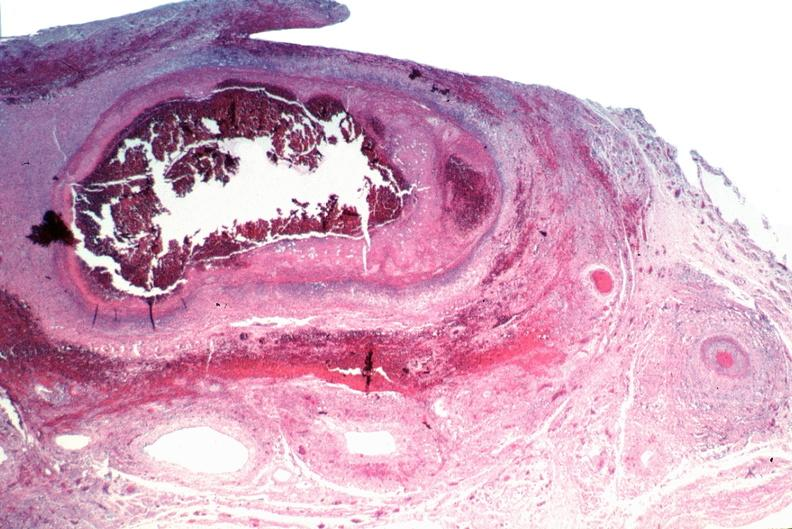s this section showing liver with tumor mass in hilar area tumor present?
Answer the question using a single word or phrase. No 